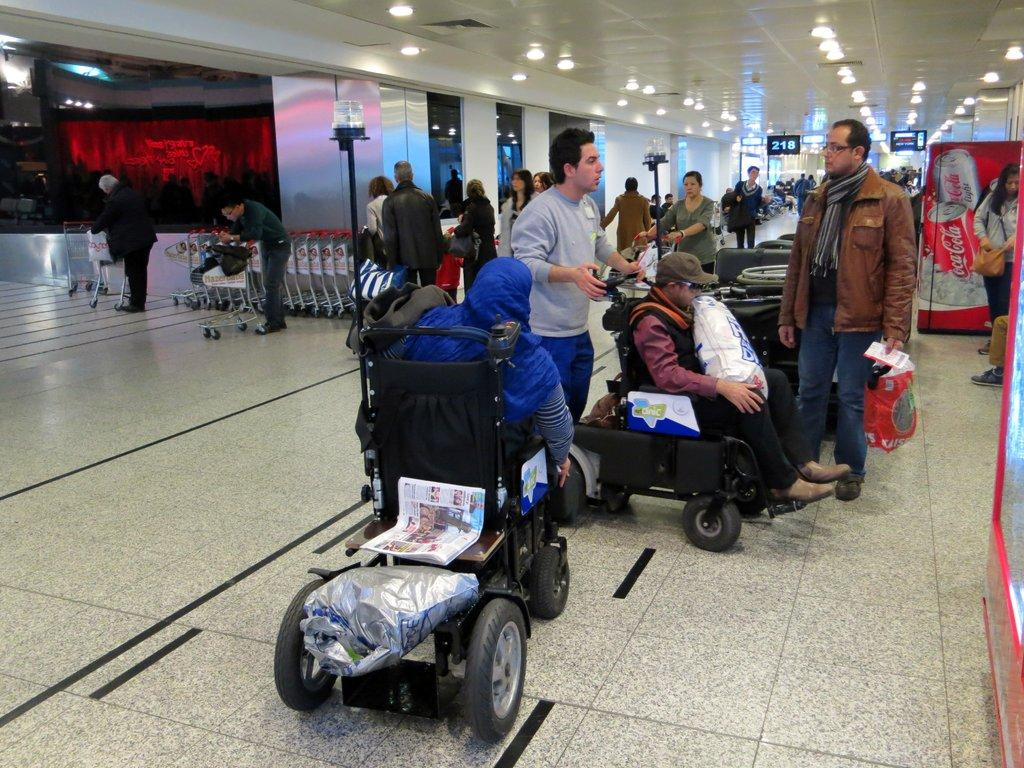<image>
Describe the image concisely. the number 218 in the distance in an airport 